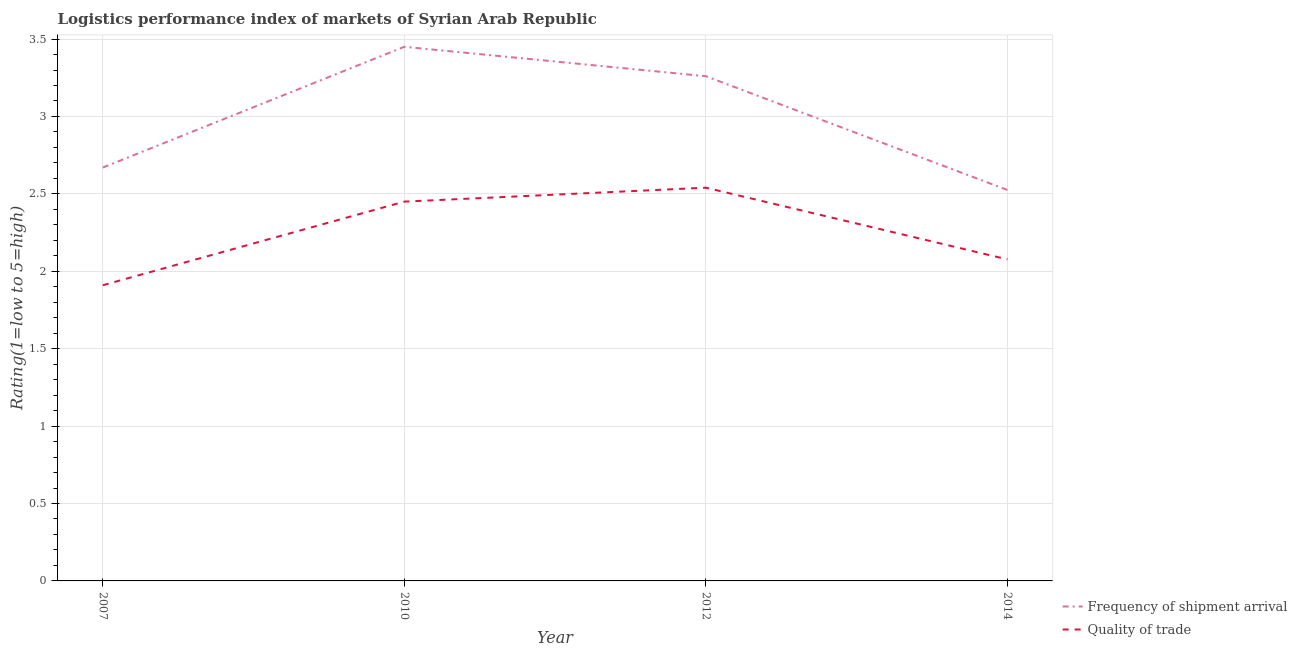How many different coloured lines are there?
Your response must be concise. 2. Does the line corresponding to lpi of frequency of shipment arrival intersect with the line corresponding to lpi quality of trade?
Provide a short and direct response. No. What is the lpi quality of trade in 2010?
Offer a very short reply. 2.45. Across all years, what is the maximum lpi quality of trade?
Ensure brevity in your answer.  2.54. Across all years, what is the minimum lpi quality of trade?
Provide a short and direct response. 1.91. In which year was the lpi quality of trade maximum?
Offer a very short reply. 2012. In which year was the lpi quality of trade minimum?
Offer a very short reply. 2007. What is the total lpi of frequency of shipment arrival in the graph?
Provide a short and direct response. 11.91. What is the difference between the lpi of frequency of shipment arrival in 2010 and that in 2014?
Your answer should be compact. 0.92. What is the difference between the lpi of frequency of shipment arrival in 2012 and the lpi quality of trade in 2010?
Offer a very short reply. 0.81. What is the average lpi of frequency of shipment arrival per year?
Give a very brief answer. 2.98. In the year 2010, what is the difference between the lpi of frequency of shipment arrival and lpi quality of trade?
Your answer should be very brief. 1. In how many years, is the lpi quality of trade greater than 1?
Give a very brief answer. 4. What is the ratio of the lpi quality of trade in 2007 to that in 2010?
Your response must be concise. 0.78. What is the difference between the highest and the second highest lpi of frequency of shipment arrival?
Your response must be concise. 0.19. What is the difference between the highest and the lowest lpi quality of trade?
Give a very brief answer. 0.63. In how many years, is the lpi quality of trade greater than the average lpi quality of trade taken over all years?
Provide a short and direct response. 2. What is the difference between two consecutive major ticks on the Y-axis?
Provide a short and direct response. 0.5. Are the values on the major ticks of Y-axis written in scientific E-notation?
Your answer should be compact. No. Does the graph contain grids?
Keep it short and to the point. Yes. How many legend labels are there?
Give a very brief answer. 2. What is the title of the graph?
Keep it short and to the point. Logistics performance index of markets of Syrian Arab Republic. What is the label or title of the X-axis?
Ensure brevity in your answer.  Year. What is the label or title of the Y-axis?
Make the answer very short. Rating(1=low to 5=high). What is the Rating(1=low to 5=high) of Frequency of shipment arrival in 2007?
Provide a short and direct response. 2.67. What is the Rating(1=low to 5=high) of Quality of trade in 2007?
Ensure brevity in your answer.  1.91. What is the Rating(1=low to 5=high) in Frequency of shipment arrival in 2010?
Make the answer very short. 3.45. What is the Rating(1=low to 5=high) in Quality of trade in 2010?
Your answer should be compact. 2.45. What is the Rating(1=low to 5=high) of Frequency of shipment arrival in 2012?
Provide a succinct answer. 3.26. What is the Rating(1=low to 5=high) in Quality of trade in 2012?
Provide a succinct answer. 2.54. What is the Rating(1=low to 5=high) of Frequency of shipment arrival in 2014?
Provide a succinct answer. 2.53. What is the Rating(1=low to 5=high) of Quality of trade in 2014?
Keep it short and to the point. 2.08. Across all years, what is the maximum Rating(1=low to 5=high) in Frequency of shipment arrival?
Ensure brevity in your answer.  3.45. Across all years, what is the maximum Rating(1=low to 5=high) in Quality of trade?
Your answer should be very brief. 2.54. Across all years, what is the minimum Rating(1=low to 5=high) of Frequency of shipment arrival?
Offer a very short reply. 2.53. Across all years, what is the minimum Rating(1=low to 5=high) in Quality of trade?
Provide a succinct answer. 1.91. What is the total Rating(1=low to 5=high) in Frequency of shipment arrival in the graph?
Provide a short and direct response. 11.9. What is the total Rating(1=low to 5=high) of Quality of trade in the graph?
Keep it short and to the point. 8.98. What is the difference between the Rating(1=low to 5=high) of Frequency of shipment arrival in 2007 and that in 2010?
Keep it short and to the point. -0.78. What is the difference between the Rating(1=low to 5=high) of Quality of trade in 2007 and that in 2010?
Provide a succinct answer. -0.54. What is the difference between the Rating(1=low to 5=high) in Frequency of shipment arrival in 2007 and that in 2012?
Your answer should be very brief. -0.59. What is the difference between the Rating(1=low to 5=high) in Quality of trade in 2007 and that in 2012?
Offer a very short reply. -0.63. What is the difference between the Rating(1=low to 5=high) in Frequency of shipment arrival in 2007 and that in 2014?
Provide a short and direct response. 0.14. What is the difference between the Rating(1=low to 5=high) in Quality of trade in 2007 and that in 2014?
Offer a very short reply. -0.17. What is the difference between the Rating(1=low to 5=high) in Frequency of shipment arrival in 2010 and that in 2012?
Ensure brevity in your answer.  0.19. What is the difference between the Rating(1=low to 5=high) of Quality of trade in 2010 and that in 2012?
Offer a very short reply. -0.09. What is the difference between the Rating(1=low to 5=high) in Frequency of shipment arrival in 2010 and that in 2014?
Your answer should be compact. 0.93. What is the difference between the Rating(1=low to 5=high) in Quality of trade in 2010 and that in 2014?
Offer a terse response. 0.37. What is the difference between the Rating(1=low to 5=high) in Frequency of shipment arrival in 2012 and that in 2014?
Offer a terse response. 0.73. What is the difference between the Rating(1=low to 5=high) in Quality of trade in 2012 and that in 2014?
Your answer should be very brief. 0.46. What is the difference between the Rating(1=low to 5=high) in Frequency of shipment arrival in 2007 and the Rating(1=low to 5=high) in Quality of trade in 2010?
Provide a short and direct response. 0.22. What is the difference between the Rating(1=low to 5=high) of Frequency of shipment arrival in 2007 and the Rating(1=low to 5=high) of Quality of trade in 2012?
Ensure brevity in your answer.  0.13. What is the difference between the Rating(1=low to 5=high) of Frequency of shipment arrival in 2007 and the Rating(1=low to 5=high) of Quality of trade in 2014?
Make the answer very short. 0.59. What is the difference between the Rating(1=low to 5=high) of Frequency of shipment arrival in 2010 and the Rating(1=low to 5=high) of Quality of trade in 2012?
Offer a terse response. 0.91. What is the difference between the Rating(1=low to 5=high) of Frequency of shipment arrival in 2010 and the Rating(1=low to 5=high) of Quality of trade in 2014?
Offer a very short reply. 1.37. What is the difference between the Rating(1=low to 5=high) of Frequency of shipment arrival in 2012 and the Rating(1=low to 5=high) of Quality of trade in 2014?
Your answer should be very brief. 1.18. What is the average Rating(1=low to 5=high) in Frequency of shipment arrival per year?
Your answer should be compact. 2.98. What is the average Rating(1=low to 5=high) in Quality of trade per year?
Provide a short and direct response. 2.24. In the year 2007, what is the difference between the Rating(1=low to 5=high) of Frequency of shipment arrival and Rating(1=low to 5=high) of Quality of trade?
Provide a succinct answer. 0.76. In the year 2012, what is the difference between the Rating(1=low to 5=high) of Frequency of shipment arrival and Rating(1=low to 5=high) of Quality of trade?
Your answer should be compact. 0.72. In the year 2014, what is the difference between the Rating(1=low to 5=high) of Frequency of shipment arrival and Rating(1=low to 5=high) of Quality of trade?
Offer a very short reply. 0.45. What is the ratio of the Rating(1=low to 5=high) in Frequency of shipment arrival in 2007 to that in 2010?
Offer a terse response. 0.77. What is the ratio of the Rating(1=low to 5=high) of Quality of trade in 2007 to that in 2010?
Offer a terse response. 0.78. What is the ratio of the Rating(1=low to 5=high) in Frequency of shipment arrival in 2007 to that in 2012?
Make the answer very short. 0.82. What is the ratio of the Rating(1=low to 5=high) in Quality of trade in 2007 to that in 2012?
Give a very brief answer. 0.75. What is the ratio of the Rating(1=low to 5=high) of Frequency of shipment arrival in 2007 to that in 2014?
Offer a terse response. 1.06. What is the ratio of the Rating(1=low to 5=high) in Quality of trade in 2007 to that in 2014?
Ensure brevity in your answer.  0.92. What is the ratio of the Rating(1=low to 5=high) in Frequency of shipment arrival in 2010 to that in 2012?
Ensure brevity in your answer.  1.06. What is the ratio of the Rating(1=low to 5=high) in Quality of trade in 2010 to that in 2012?
Make the answer very short. 0.96. What is the ratio of the Rating(1=low to 5=high) in Frequency of shipment arrival in 2010 to that in 2014?
Your answer should be very brief. 1.37. What is the ratio of the Rating(1=low to 5=high) of Quality of trade in 2010 to that in 2014?
Keep it short and to the point. 1.18. What is the ratio of the Rating(1=low to 5=high) in Frequency of shipment arrival in 2012 to that in 2014?
Offer a very short reply. 1.29. What is the ratio of the Rating(1=low to 5=high) in Quality of trade in 2012 to that in 2014?
Provide a short and direct response. 1.22. What is the difference between the highest and the second highest Rating(1=low to 5=high) in Frequency of shipment arrival?
Ensure brevity in your answer.  0.19. What is the difference between the highest and the second highest Rating(1=low to 5=high) of Quality of trade?
Offer a very short reply. 0.09. What is the difference between the highest and the lowest Rating(1=low to 5=high) of Frequency of shipment arrival?
Provide a short and direct response. 0.93. What is the difference between the highest and the lowest Rating(1=low to 5=high) of Quality of trade?
Make the answer very short. 0.63. 